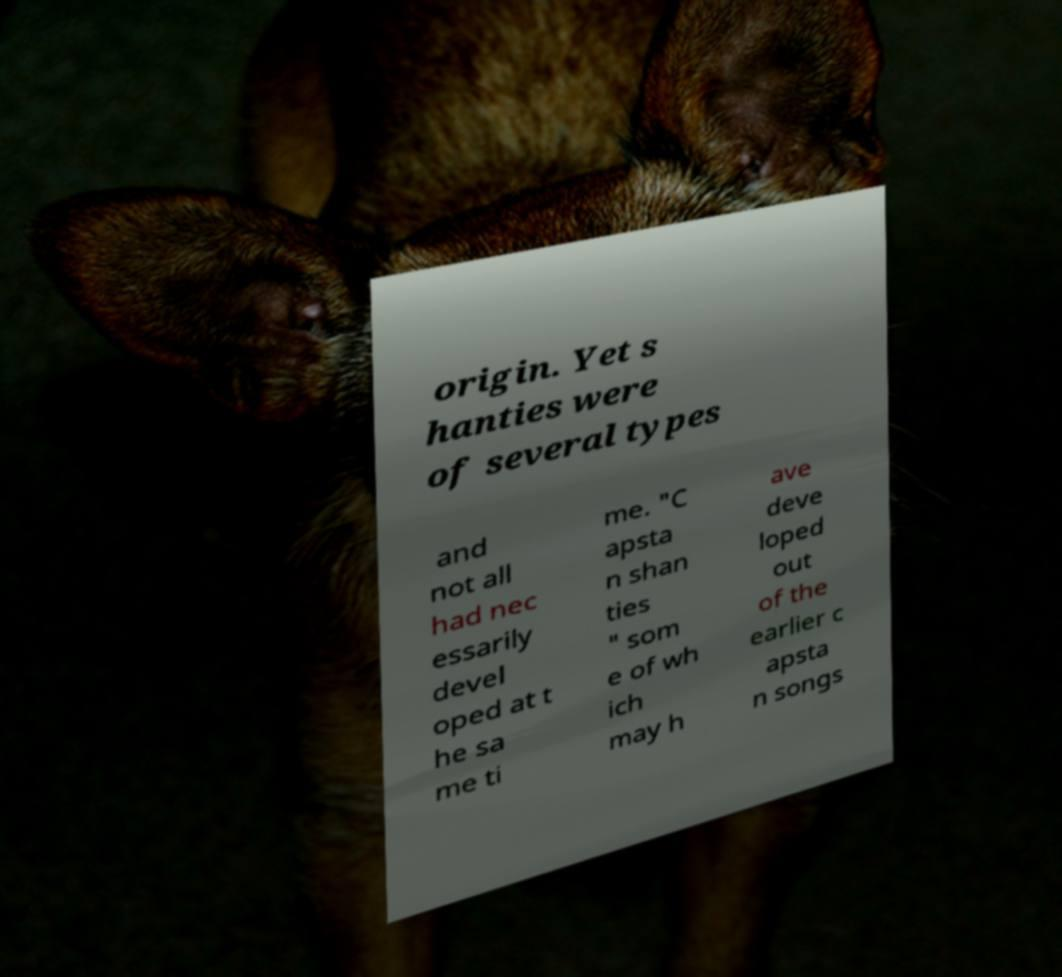Could you extract and type out the text from this image? origin. Yet s hanties were of several types and not all had nec essarily devel oped at t he sa me ti me. "C apsta n shan ties " som e of wh ich may h ave deve loped out of the earlier c apsta n songs 